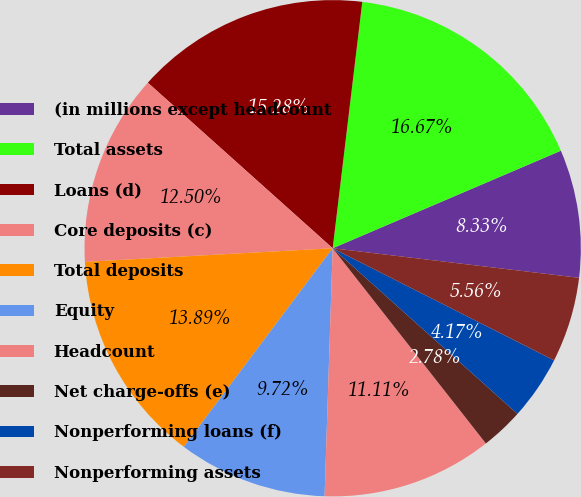Convert chart. <chart><loc_0><loc_0><loc_500><loc_500><pie_chart><fcel>(in millions except headcount<fcel>Total assets<fcel>Loans (d)<fcel>Core deposits (c)<fcel>Total deposits<fcel>Equity<fcel>Headcount<fcel>Net charge-offs (e)<fcel>Nonperforming loans (f)<fcel>Nonperforming assets<nl><fcel>8.33%<fcel>16.67%<fcel>15.28%<fcel>12.5%<fcel>13.89%<fcel>9.72%<fcel>11.11%<fcel>2.78%<fcel>4.17%<fcel>5.56%<nl></chart> 